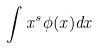<formula> <loc_0><loc_0><loc_500><loc_500>\int x ^ { s } \phi ( x ) d x</formula> 